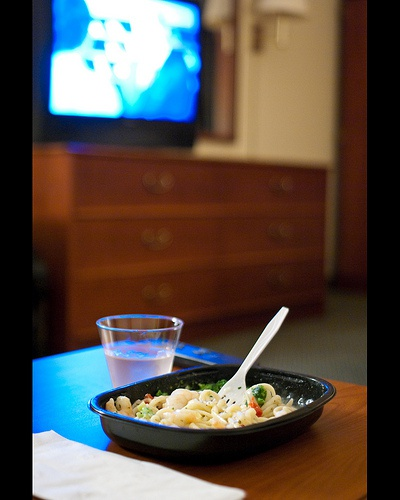Describe the objects in this image and their specific colors. I can see dining table in black, lightgray, maroon, and lightblue tones, tv in black, white, lightblue, and navy tones, bowl in black, ivory, and tan tones, cup in black, darkgray, brown, and lightblue tones, and fork in black, lightgray, tan, and darkgray tones in this image. 